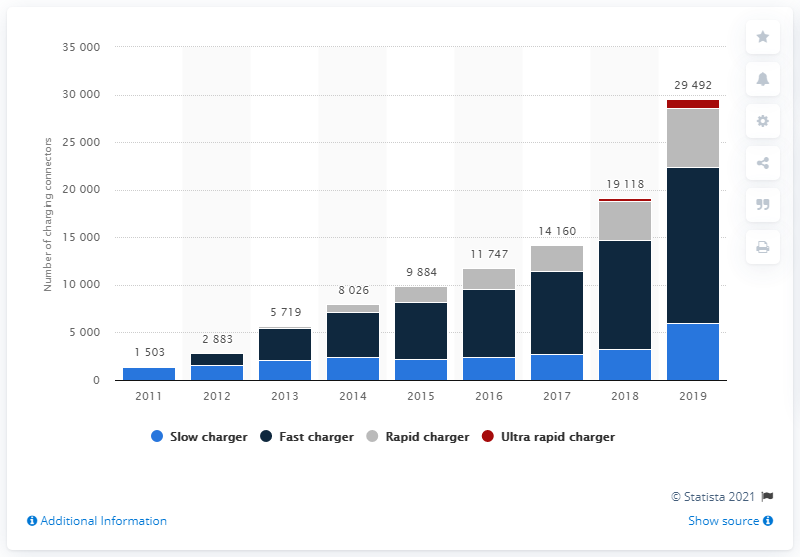Draw attention to some important aspects in this diagram. In the year 2019, there were 876 ultra-rapid chargers in the United Kingdom. 